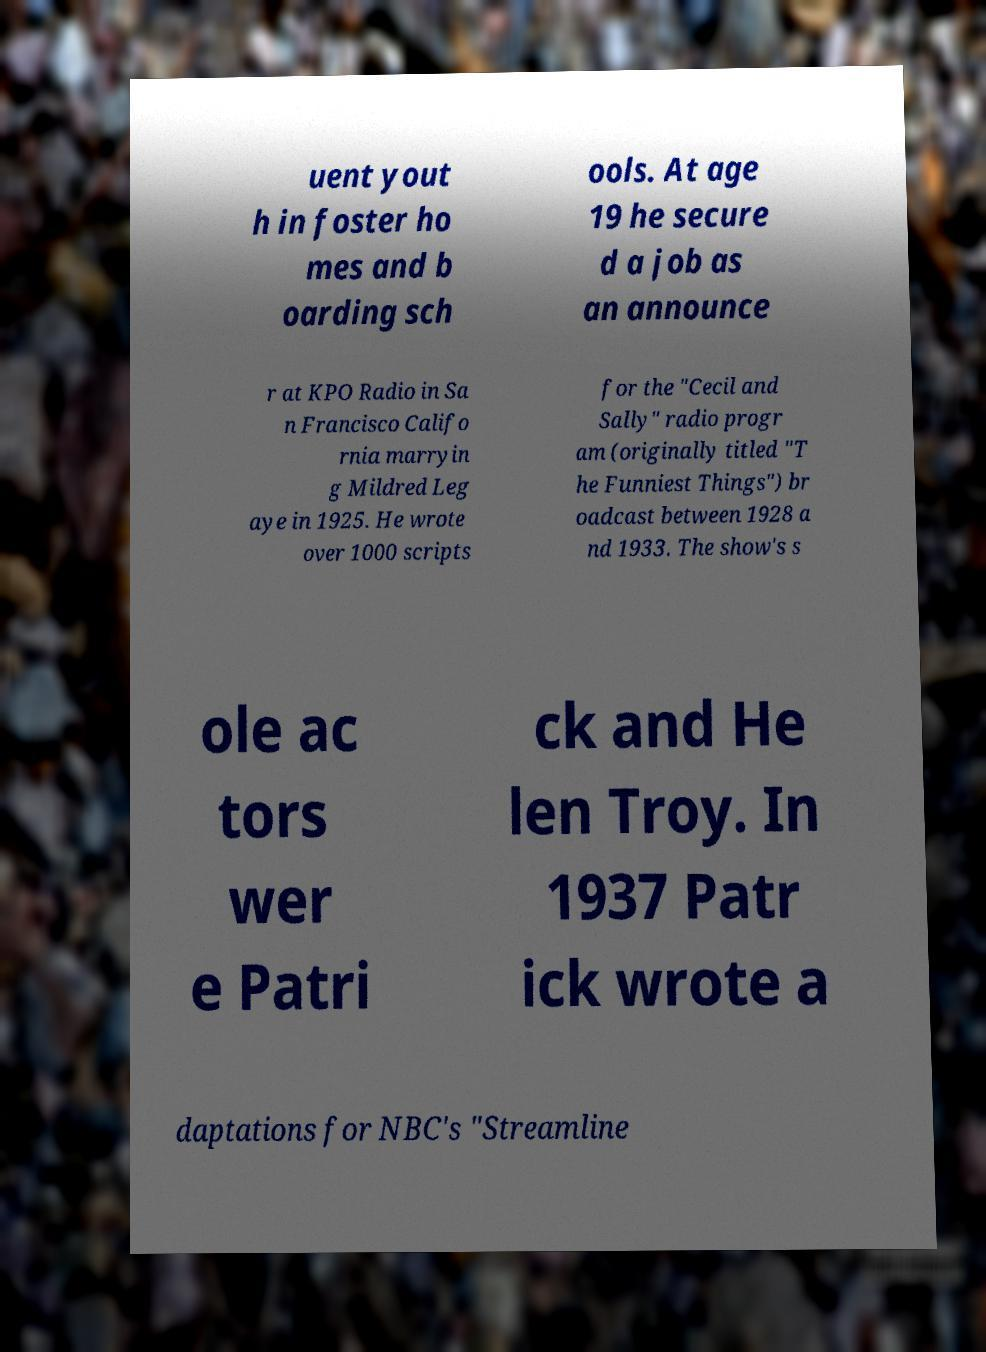Can you read and provide the text displayed in the image?This photo seems to have some interesting text. Can you extract and type it out for me? uent yout h in foster ho mes and b oarding sch ools. At age 19 he secure d a job as an announce r at KPO Radio in Sa n Francisco Califo rnia marryin g Mildred Leg aye in 1925. He wrote over 1000 scripts for the "Cecil and Sally" radio progr am (originally titled "T he Funniest Things") br oadcast between 1928 a nd 1933. The show's s ole ac tors wer e Patri ck and He len Troy. In 1937 Patr ick wrote a daptations for NBC's "Streamline 